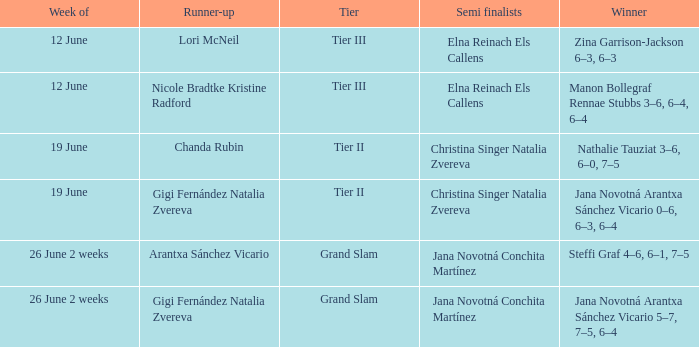In which week is the winner listed as Jana Novotná Arantxa Sánchez Vicario 5–7, 7–5, 6–4? 26 June 2 weeks. 